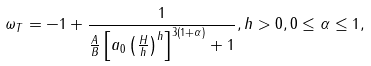<formula> <loc_0><loc_0><loc_500><loc_500>\omega _ { T } = - 1 + \frac { 1 } { \frac { A } { B } \left [ a _ { 0 } \left ( \frac { H } { h } \right ) ^ { h } \right ] ^ { 3 ( 1 + \alpha ) } + 1 } , h > 0 , 0 \leq \alpha \leq 1 ,</formula> 